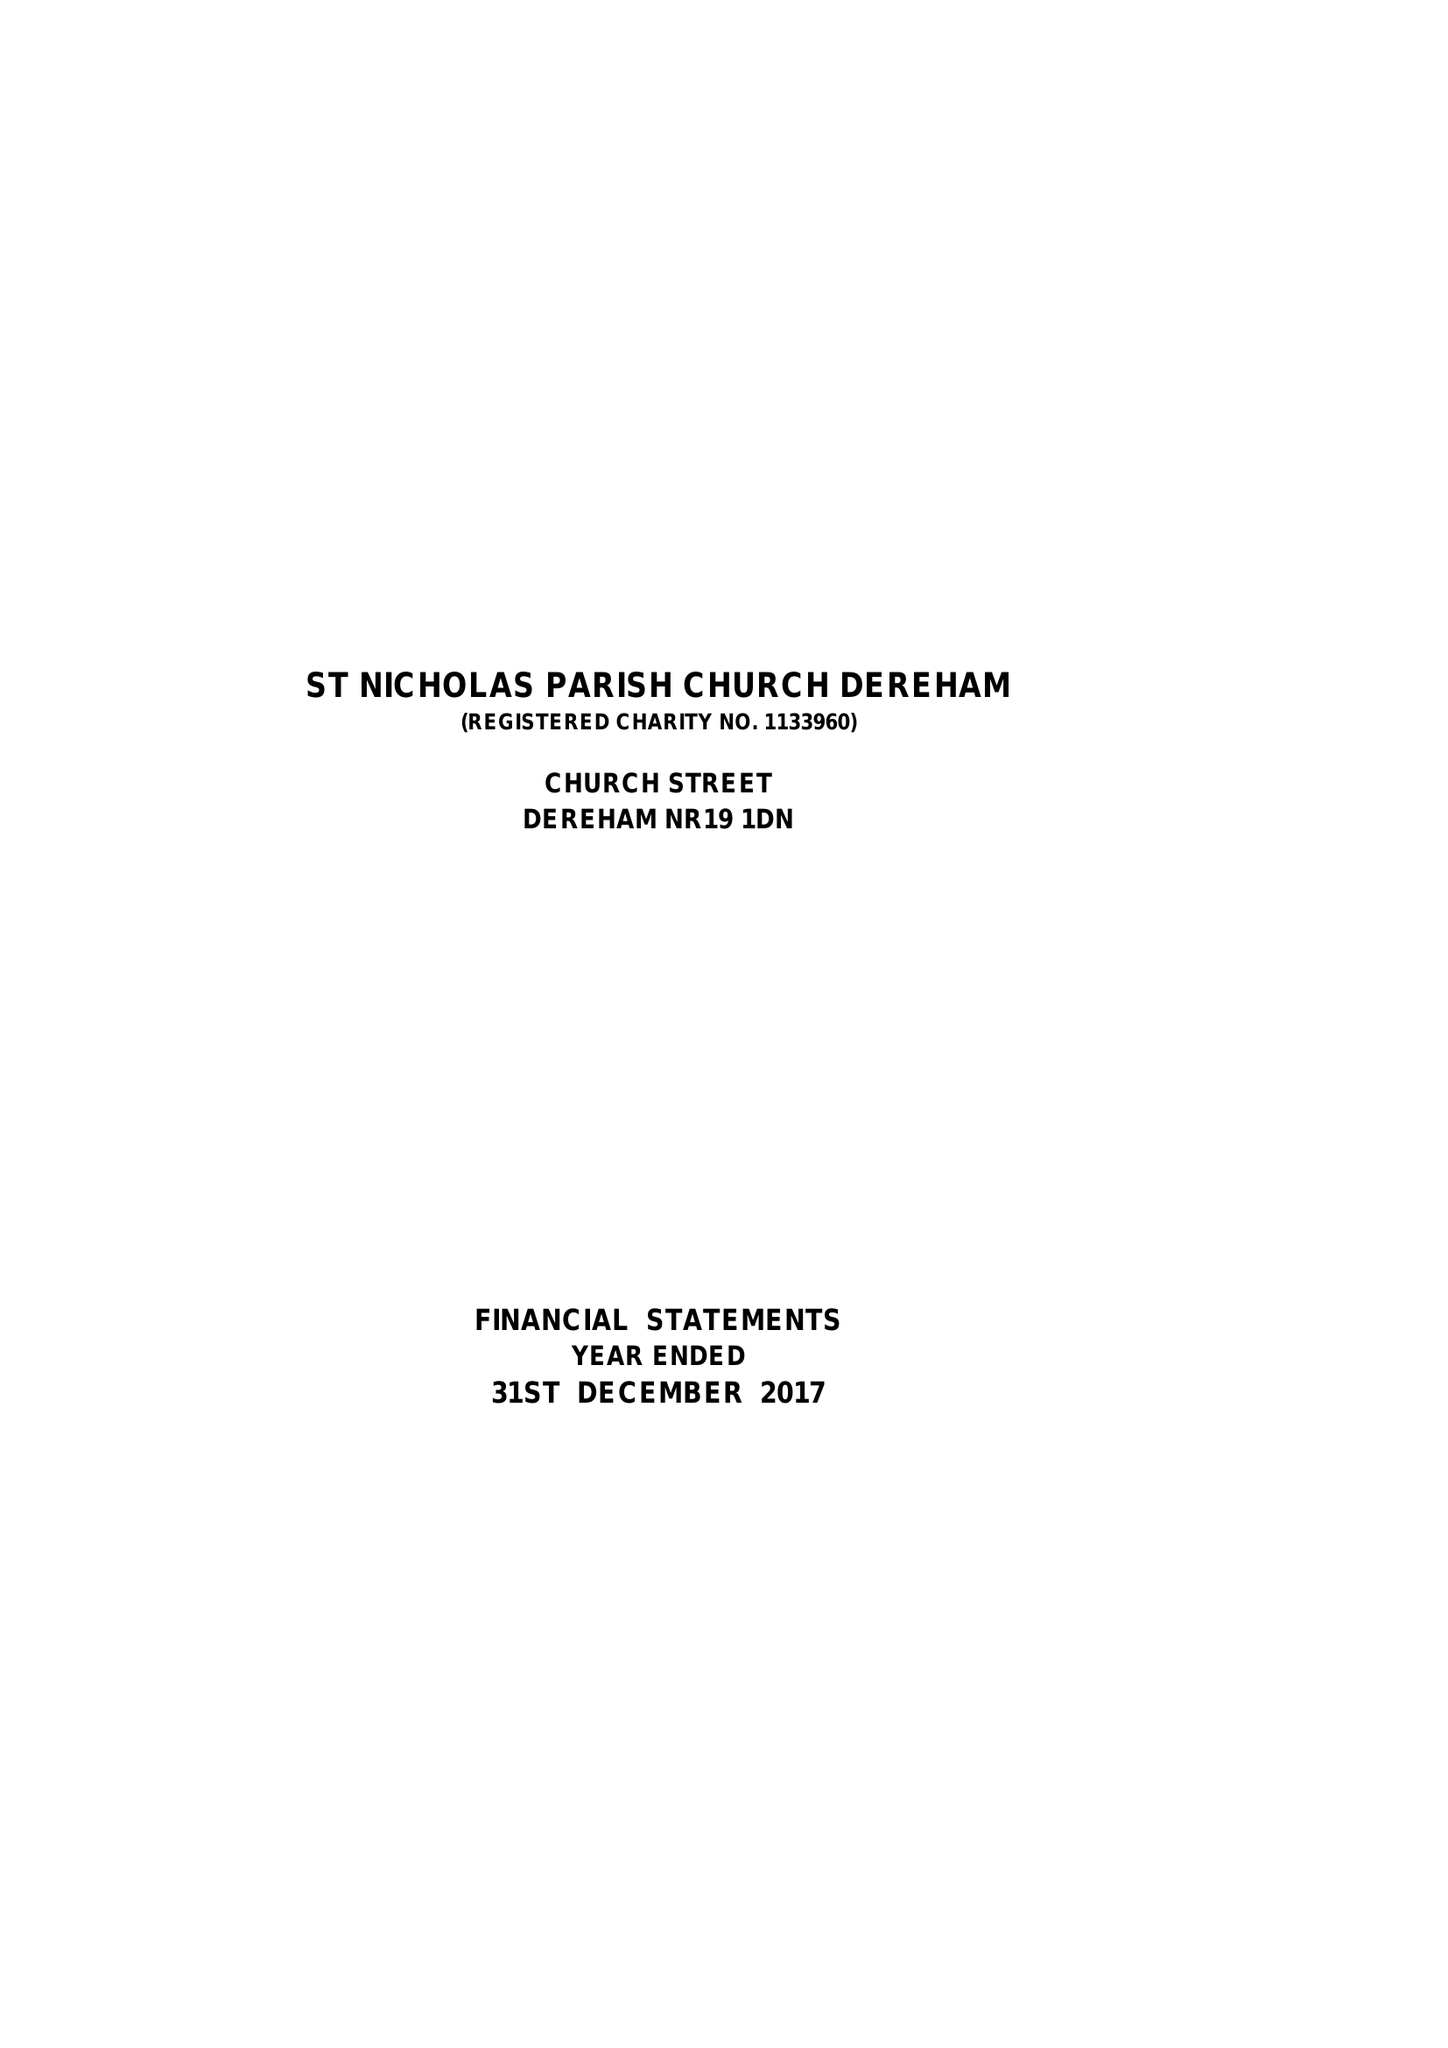What is the value for the report_date?
Answer the question using a single word or phrase. 2017-12-31 